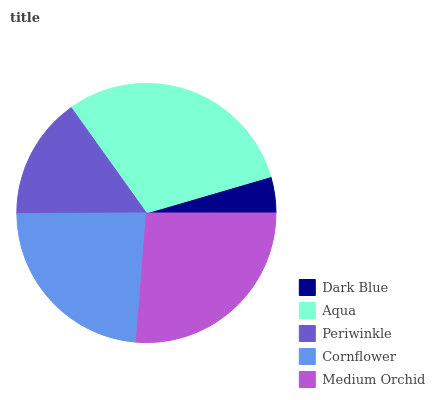Is Dark Blue the minimum?
Answer yes or no. Yes. Is Aqua the maximum?
Answer yes or no. Yes. Is Periwinkle the minimum?
Answer yes or no. No. Is Periwinkle the maximum?
Answer yes or no. No. Is Aqua greater than Periwinkle?
Answer yes or no. Yes. Is Periwinkle less than Aqua?
Answer yes or no. Yes. Is Periwinkle greater than Aqua?
Answer yes or no. No. Is Aqua less than Periwinkle?
Answer yes or no. No. Is Cornflower the high median?
Answer yes or no. Yes. Is Cornflower the low median?
Answer yes or no. Yes. Is Dark Blue the high median?
Answer yes or no. No. Is Dark Blue the low median?
Answer yes or no. No. 